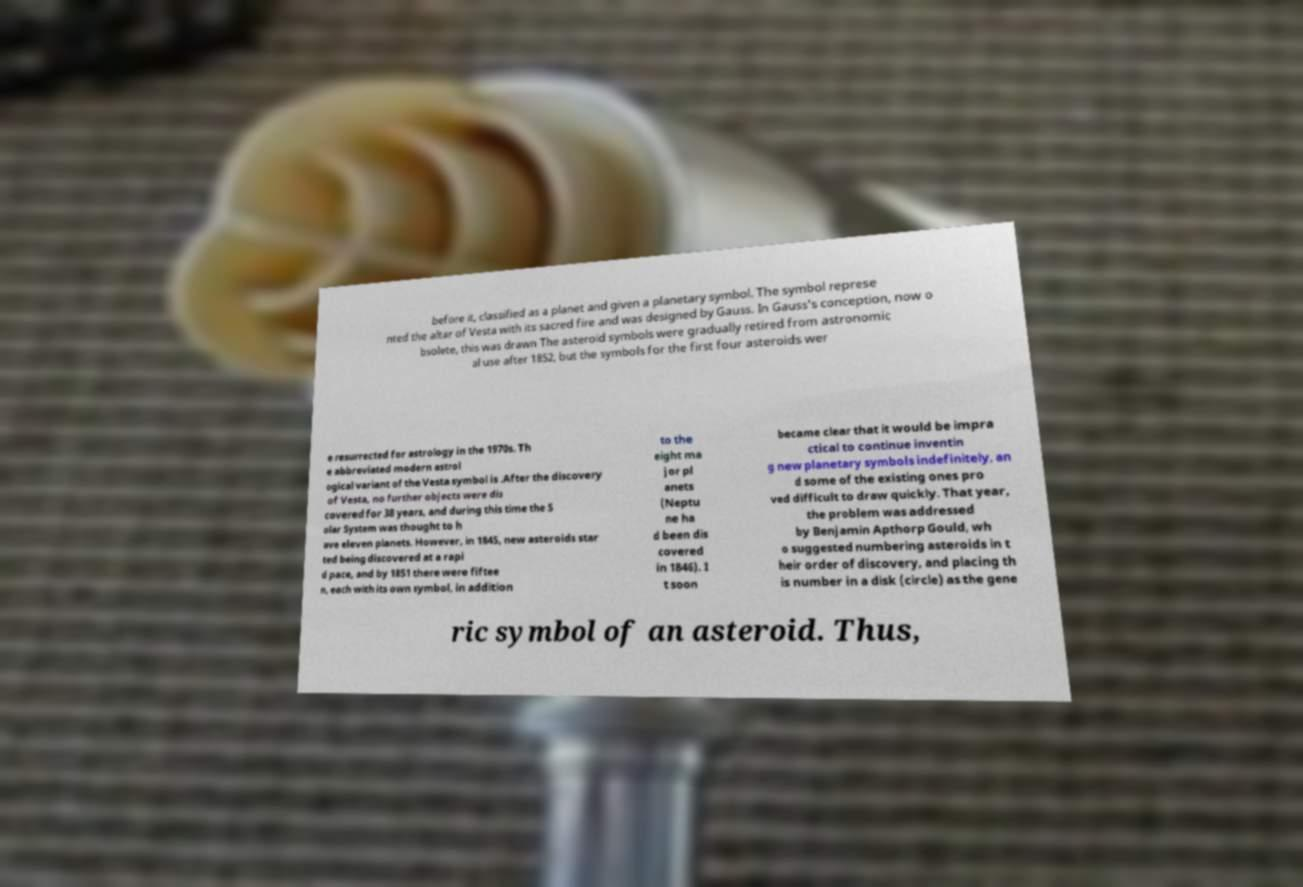Could you assist in decoding the text presented in this image and type it out clearly? before it, classified as a planet and given a planetary symbol. The symbol represe nted the altar of Vesta with its sacred fire and was designed by Gauss. In Gauss's conception, now o bsolete, this was drawn The asteroid symbols were gradually retired from astronomic al use after 1852, but the symbols for the first four asteroids wer e resurrected for astrology in the 1970s. Th e abbreviated modern astrol ogical variant of the Vesta symbol is .After the discovery of Vesta, no further objects were dis covered for 38 years, and during this time the S olar System was thought to h ave eleven planets. However, in 1845, new asteroids star ted being discovered at a rapi d pace, and by 1851 there were fiftee n, each with its own symbol, in addition to the eight ma jor pl anets (Neptu ne ha d been dis covered in 1846). I t soon became clear that it would be impra ctical to continue inventin g new planetary symbols indefinitely, an d some of the existing ones pro ved difficult to draw quickly. That year, the problem was addressed by Benjamin Apthorp Gould, wh o suggested numbering asteroids in t heir order of discovery, and placing th is number in a disk (circle) as the gene ric symbol of an asteroid. Thus, 